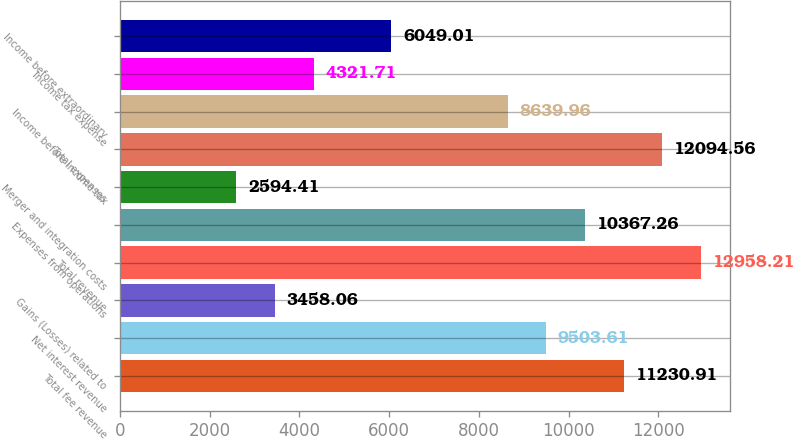<chart> <loc_0><loc_0><loc_500><loc_500><bar_chart><fcel>Total fee revenue<fcel>Net interest revenue<fcel>Gains (Losses) related to<fcel>Total revenue<fcel>Expenses from operations<fcel>Merger and integration costs<fcel>Total expenses<fcel>Income before income tax<fcel>Income tax expense<fcel>Income before extraordinary<nl><fcel>11230.9<fcel>9503.61<fcel>3458.06<fcel>12958.2<fcel>10367.3<fcel>2594.41<fcel>12094.6<fcel>8639.96<fcel>4321.71<fcel>6049.01<nl></chart> 